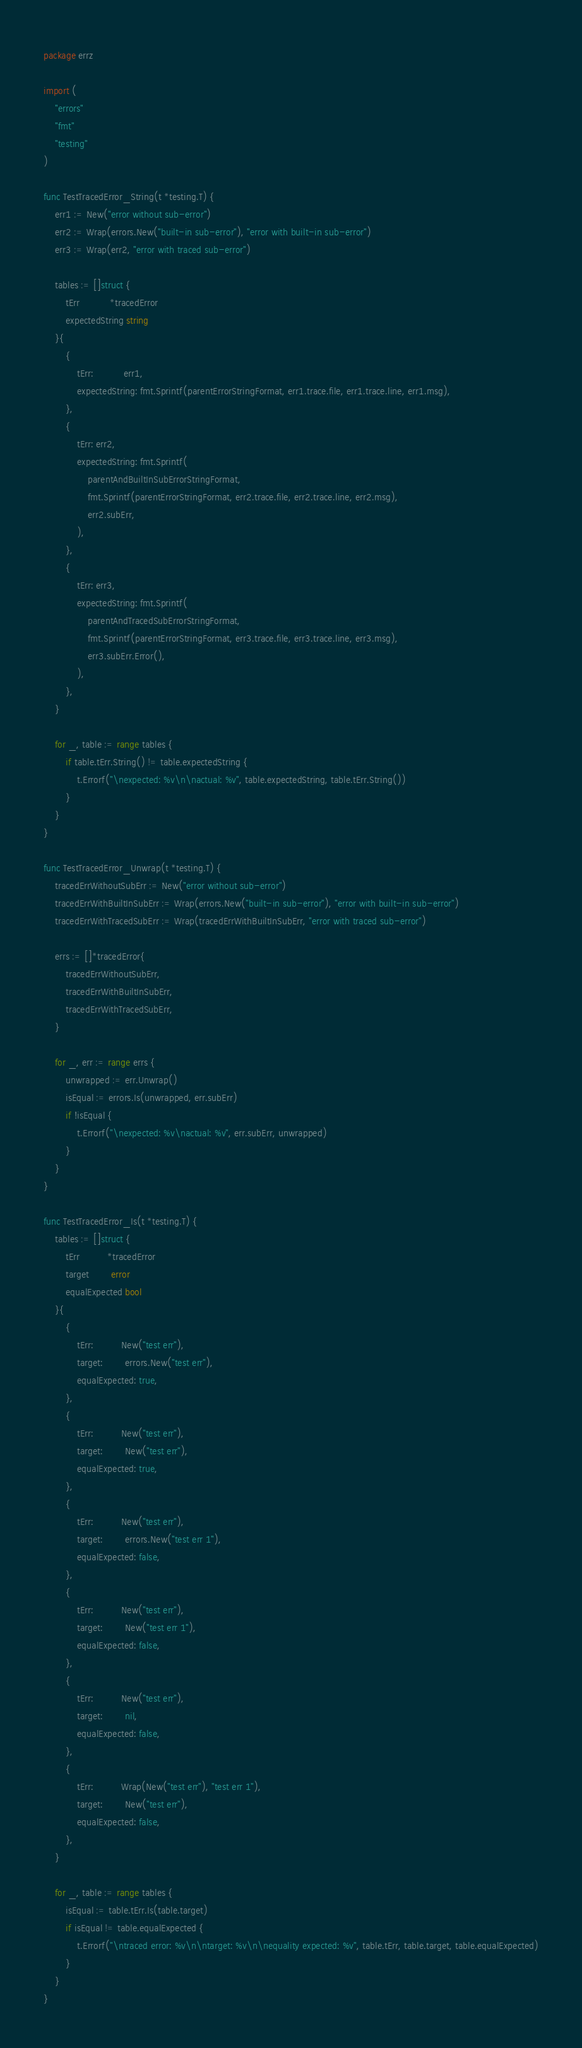<code> <loc_0><loc_0><loc_500><loc_500><_Go_>package errz

import (
	"errors"
	"fmt"
	"testing"
)

func TestTracedError_String(t *testing.T) {
	err1 := New("error without sub-error")
	err2 := Wrap(errors.New("built-in sub-error"), "error with built-in sub-error")
	err3 := Wrap(err2, "error with traced sub-error")

	tables := []struct {
		tErr           *tracedError
		expectedString string
	}{
		{
			tErr:           err1,
			expectedString: fmt.Sprintf(parentErrorStringFormat, err1.trace.file, err1.trace.line, err1.msg),
		},
		{
			tErr: err2,
			expectedString: fmt.Sprintf(
				parentAndBuiltInSubErrorStringFormat,
				fmt.Sprintf(parentErrorStringFormat, err2.trace.file, err2.trace.line, err2.msg),
				err2.subErr,
			),
		},
		{
			tErr: err3,
			expectedString: fmt.Sprintf(
				parentAndTracedSubErrorStringFormat,
				fmt.Sprintf(parentErrorStringFormat, err3.trace.file, err3.trace.line, err3.msg),
				err3.subErr.Error(),
			),
		},
	}

	for _, table := range tables {
		if table.tErr.String() != table.expectedString {
			t.Errorf("\nexpected: %v\n\nactual: %v", table.expectedString, table.tErr.String())
		}
	}
}

func TestTracedError_Unwrap(t *testing.T) {
	tracedErrWithoutSubErr := New("error without sub-error")
	tracedErrWithBuiltInSubErr := Wrap(errors.New("built-in sub-error"), "error with built-in sub-error")
	tracedErrWithTracedSubErr := Wrap(tracedErrWithBuiltInSubErr, "error with traced sub-error")

	errs := []*tracedError{
		tracedErrWithoutSubErr,
		tracedErrWithBuiltInSubErr,
		tracedErrWithTracedSubErr,
	}

	for _, err := range errs {
		unwrapped := err.Unwrap()
		isEqual := errors.Is(unwrapped, err.subErr)
		if !isEqual {
			t.Errorf("\nexpected: %v\nactual: %v", err.subErr, unwrapped)
		}
	}
}

func TestTracedError_Is(t *testing.T) {
	tables := []struct {
		tErr          *tracedError
		target        error
		equalExpected bool
	}{
		{
			tErr:          New("test err"),
			target:        errors.New("test err"),
			equalExpected: true,
		},
		{
			tErr:          New("test err"),
			target:        New("test err"),
			equalExpected: true,
		},
		{
			tErr:          New("test err"),
			target:        errors.New("test err 1"),
			equalExpected: false,
		},
		{
			tErr:          New("test err"),
			target:        New("test err 1"),
			equalExpected: false,
		},
		{
			tErr:          New("test err"),
			target:        nil,
			equalExpected: false,
		},
		{
			tErr:          Wrap(New("test err"), "test err 1"),
			target:        New("test err"),
			equalExpected: false,
		},
	}

	for _, table := range tables {
		isEqual := table.tErr.Is(table.target)
		if isEqual != table.equalExpected {
			t.Errorf("\ntraced error: %v\n\ntarget: %v\n\nequality expected: %v", table.tErr, table.target, table.equalExpected)
		}
	}
}
</code> 